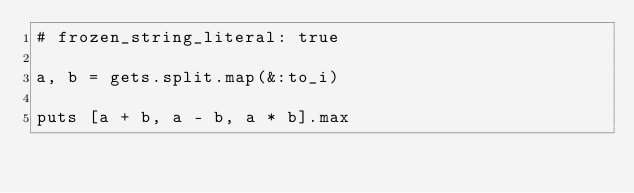Convert code to text. <code><loc_0><loc_0><loc_500><loc_500><_Ruby_># frozen_string_literal: true

a, b = gets.split.map(&:to_i)

puts [a + b, a - b, a * b].max</code> 